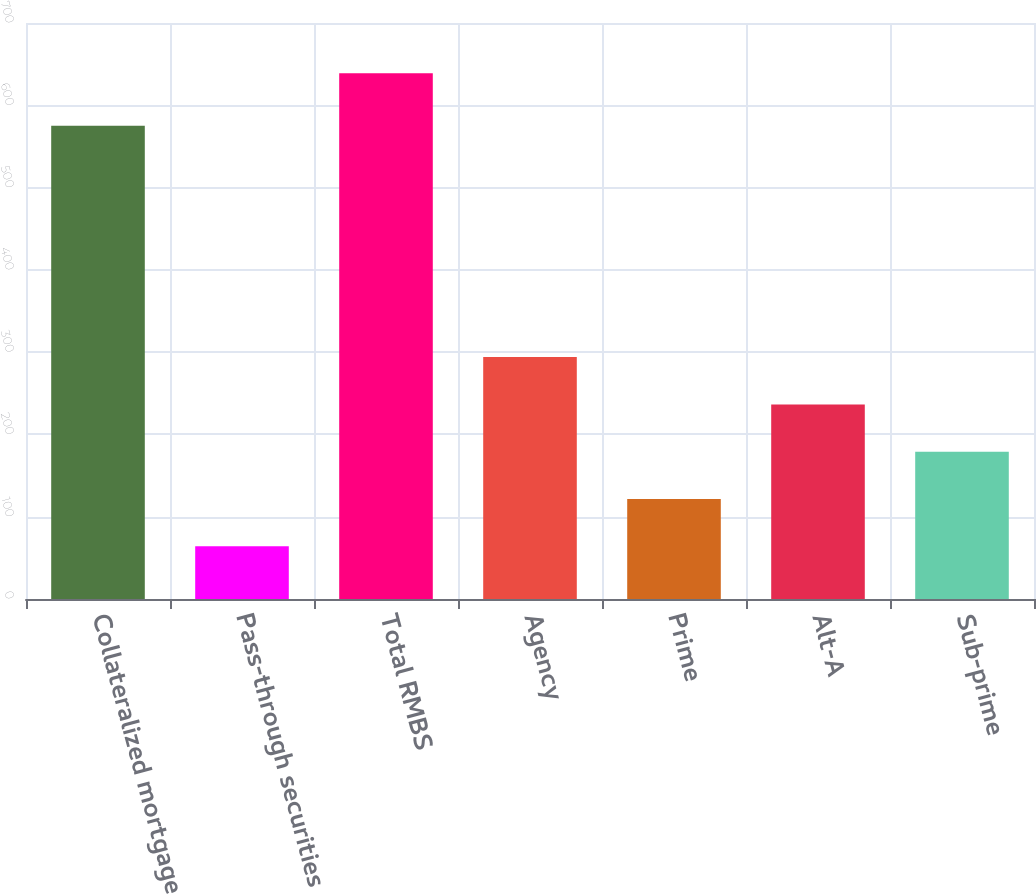Convert chart to OTSL. <chart><loc_0><loc_0><loc_500><loc_500><bar_chart><fcel>Collateralized mortgage<fcel>Pass-through securities<fcel>Total RMBS<fcel>Agency<fcel>Prime<fcel>Alt-A<fcel>Sub-prime<nl><fcel>575<fcel>64<fcel>639<fcel>294<fcel>121.5<fcel>236.5<fcel>179<nl></chart> 